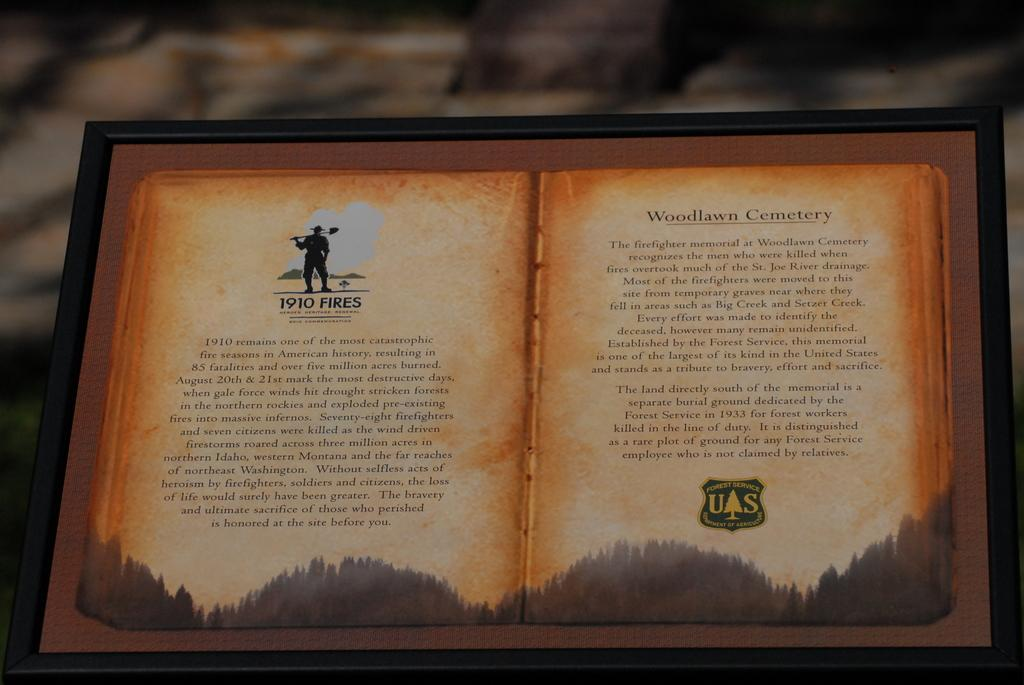Provide a one-sentence caption for the provided image. A book is open to a page about Woodlawn Cemetery. 